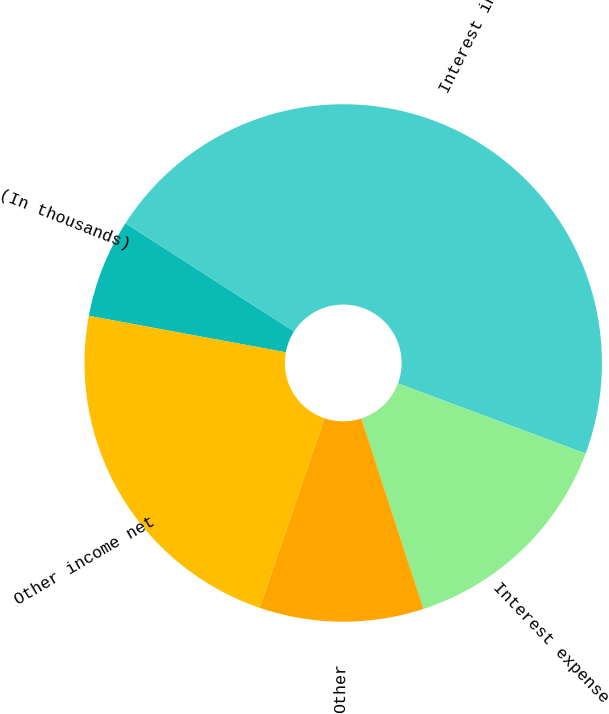<chart> <loc_0><loc_0><loc_500><loc_500><pie_chart><fcel>(In thousands)<fcel>Interest income<fcel>Interest expense<fcel>Other<fcel>Other income net<nl><fcel>6.16%<fcel>46.62%<fcel>14.29%<fcel>10.25%<fcel>22.68%<nl></chart> 